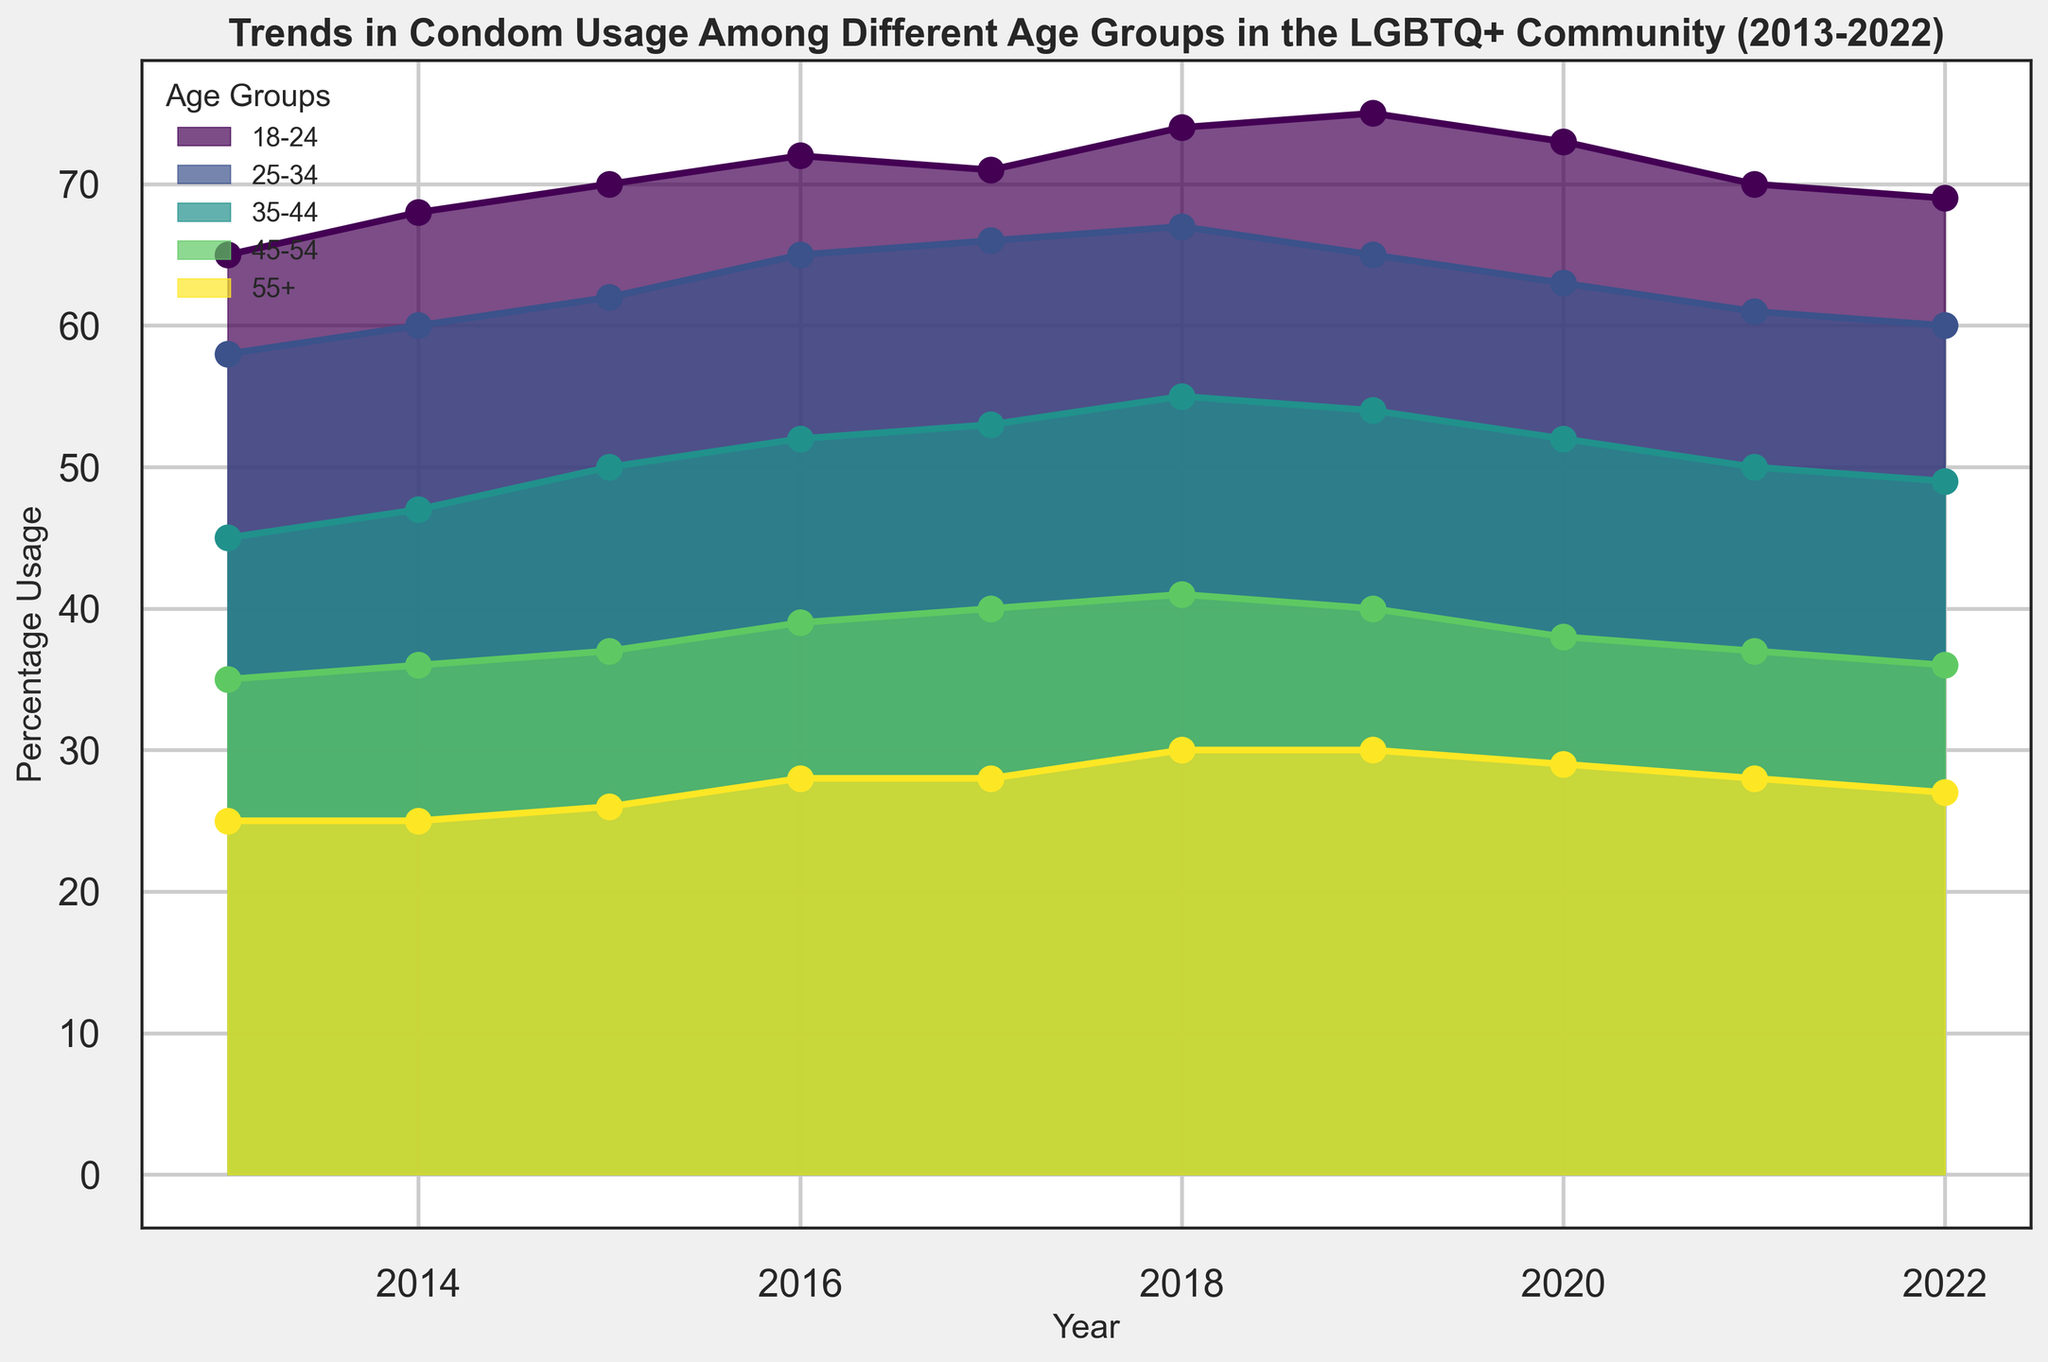What is the overall trend in condom usage among the 18-24 age group from 2013 to 2022? To determine the overall trend, observe the changes in percentages over time for the 18-24 age group. Starting from 65% in 2013, there is a steady rise until 2019 reaching 75%, followed by a slight decline to 69% in 2022. The overall trend is an initial increase followed by a slight decline in recent years.
Answer: Increasing then slightly decreasing Which age group had the highest percentage usage in 2019, and what was it? To find this, look for the peak points of the filled areas in the chart for 2019. The highest point among all the age groups is the 18-24 age group at 75%.
Answer: 18-24, 75% Compare the condom usage trends between the 35-44 and 45-54 age groups between 2013 and 2022. Which group showed a greater percentage increase? Calculate the increase for each age group. For 35-44, the percentage rose from 45% in 2013 to 49% in 2022 (4 percentage points). For 45-54, it increased from 35% in 2013 to 36% in 2022 (1 percentage point). Hence, the 35-44 age group showed a greater increase.
Answer: 35-44 What is the difference between the highest and lowest percentage usage for the 25-34 age group over the past decade? Identify the highest and lowest percentage usage for 25-34 from the figure. The highest was 67% in 2018, and the lowest was 58% in 2013. The difference is 67% - 58% = 9 percentage points.
Answer: 9 percentage points Which age group had a percentage usage equal to 50% in 2015? To answer this, locate the bars corresponding to the year 2015 and identify the one marked at 50%. The 35-44 age group had a usage of 50% in 2015.
Answer: 35-44 Between which consecutive years did the 18-24 age group experience the steepest decline in condom usage? To determine the steepest decline, observe the sharpest drop in the plotted line for the 18-24 age group. The steepest decline occurred between 2019 and 2020, where the percentage dropped from 75% to 73% (2 percentage points).
Answer: 2019 to 2020 In 2017, which age group had a lower condom usage percentage – 45-54 or 55+? Refer to the values of each age group in 2017. The 45-54 age group had a percentage usage of 40%, whereas the 55+ age group had 28%. Therefore, the 55+ age group had a lower percentage.
Answer: 55+ What is the average percentage usage for the 35-44 age group over the entire period shown? To find the average, sum the percentages from 2013 to 2022 and then divide by the number of years. The total is 45 + 47 + 50 + 52 + 53 + 55 + 54 + 52 + 50 + 49 = 507. The average is 507/10 = 50.7
Answer: 50.7 In which year did the 55+ age group's condom usage first match or exceed 30%? Locate the years where the 55+ usage hits or surpasses 30%. It was first achieved in 2018 with exactly 30%.
Answer: 2018 